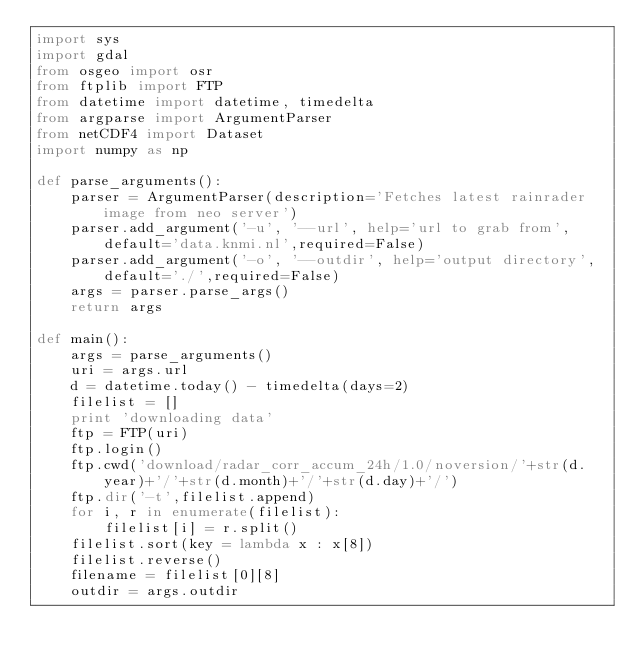<code> <loc_0><loc_0><loc_500><loc_500><_Python_>import sys
import gdal
from osgeo import osr
from ftplib import FTP
from datetime import datetime, timedelta
from argparse import ArgumentParser
from netCDF4 import Dataset
import numpy as np

def parse_arguments():
	parser = ArgumentParser(description='Fetches latest rainrader  image from neo server')
	parser.add_argument('-u', '--url', help='url to grab from', default='data.knmi.nl',required=False)
	parser.add_argument('-o', '--outdir', help='output directory', default='./',required=False)
	args = parser.parse_args()
	return args
    
def main():
	args = parse_arguments()
	uri = args.url
	d = datetime.today() - timedelta(days=2)
	filelist = []
	print 'downloading data'
	ftp = FTP(uri)
	ftp.login()
	ftp.cwd('download/radar_corr_accum_24h/1.0/noversion/'+str(d.year)+'/'+str(d.month)+'/'+str(d.day)+'/')
	ftp.dir('-t',filelist.append)
	for i, r in enumerate(filelist):
		filelist[i] = r.split()
	filelist.sort(key = lambda x : x[8])
	filelist.reverse()
	filename = filelist[0][8]
	outdir = args.outdir</code> 